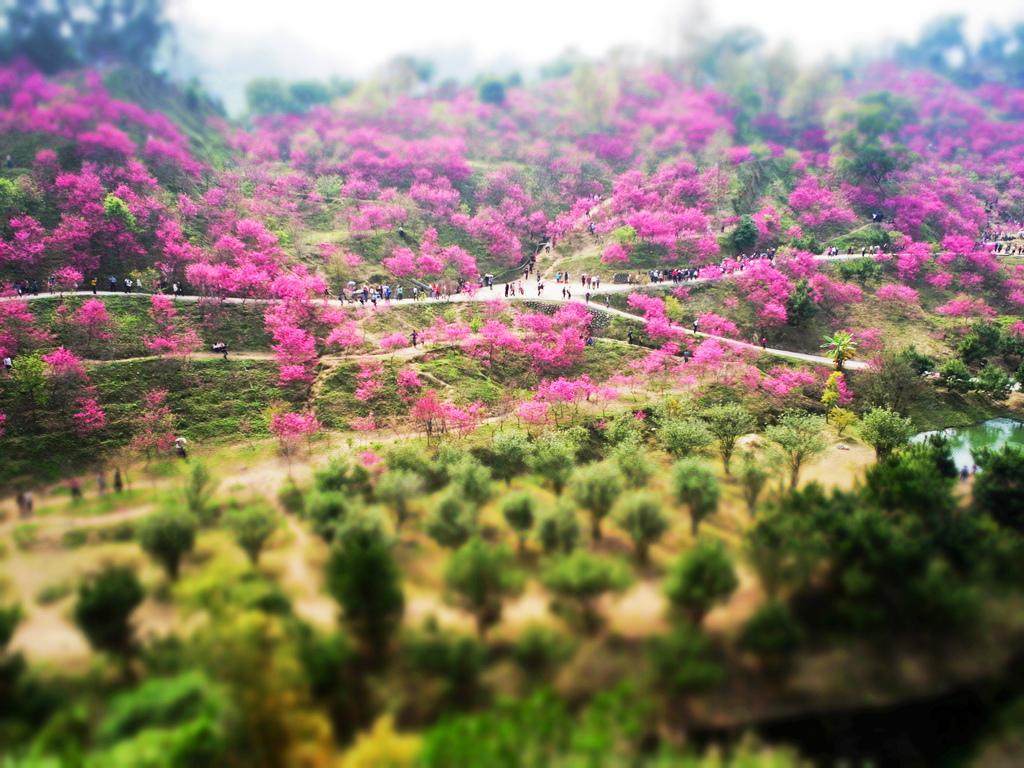Please provide a concise description of this image. In this image few trees are on the grassland. Few persons are standing on the road. Top of image there is sky. Few persons are standing on the land. 